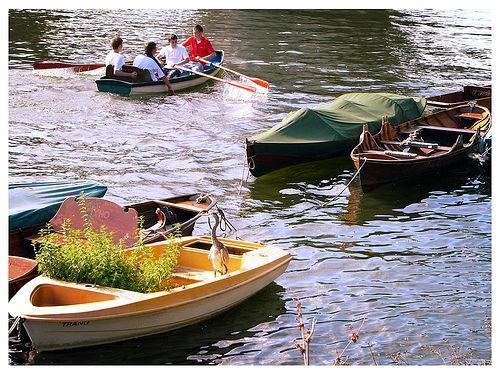How many boats are in use?
Give a very brief answer. 1. How many of the boats are covered?
Give a very brief answer. 2. How many boats are there?
Give a very brief answer. 6. 